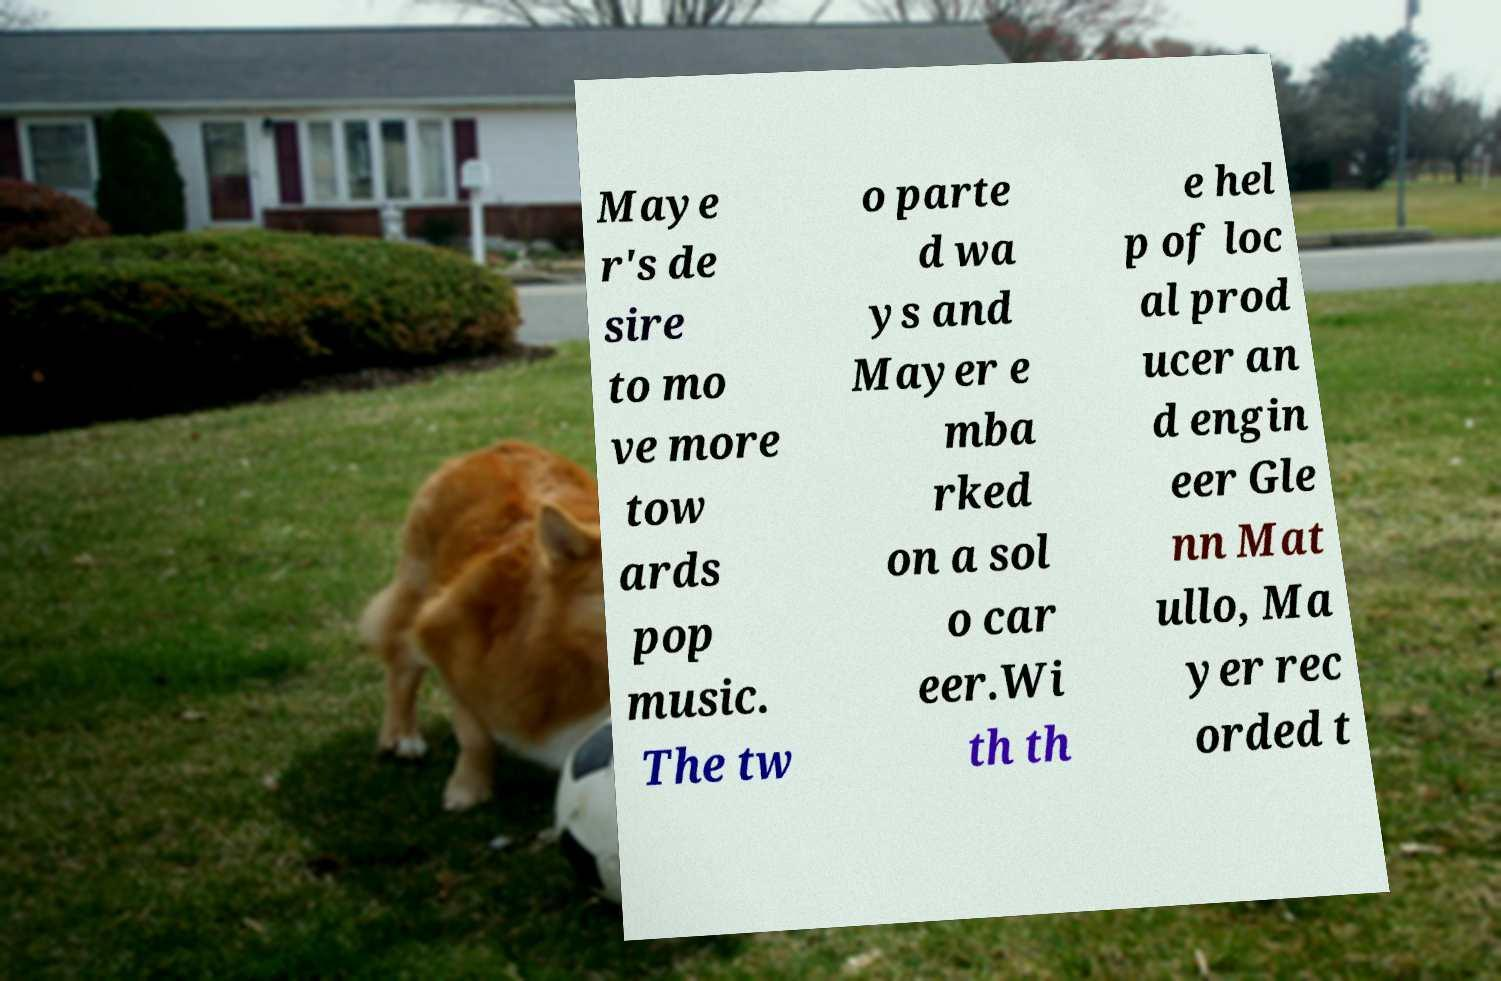Could you assist in decoding the text presented in this image and type it out clearly? Maye r's de sire to mo ve more tow ards pop music. The tw o parte d wa ys and Mayer e mba rked on a sol o car eer.Wi th th e hel p of loc al prod ucer an d engin eer Gle nn Mat ullo, Ma yer rec orded t 